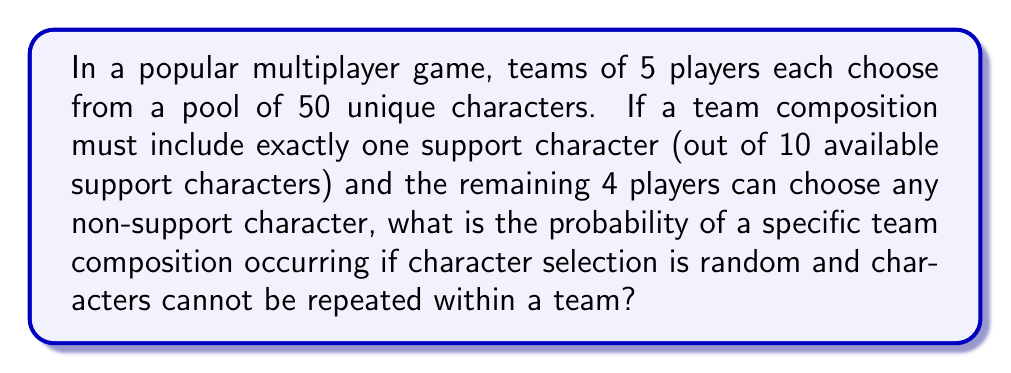What is the answer to this math problem? Let's break this down step-by-step:

1) First, we need to choose the support character:
   - There are 10 support characters to choose from
   - We need to select 1
   - This can be done in $\binom{10}{1} = 10$ ways

2) For the remaining 4 players:
   - There are 50 - 10 = 40 non-support characters to choose from
   - We need to select 4
   - This can be done in $\binom{40}{4}$ ways

3) Calculate $\binom{40}{4}$:
   $$\binom{40}{4} = \frac{40!}{4!(40-4)!} = \frac{40!}{4!36!} = 91,390$$

4) The total number of possible team compositions is:
   $$10 \times 91,390 = 913,900$$

5) The probability of a specific team composition occurring is:
   $$\frac{1}{913,900}$$

This is because each specific composition is equally likely, and there are 913,900 possible compositions.
Answer: $\frac{1}{913,900}$ 